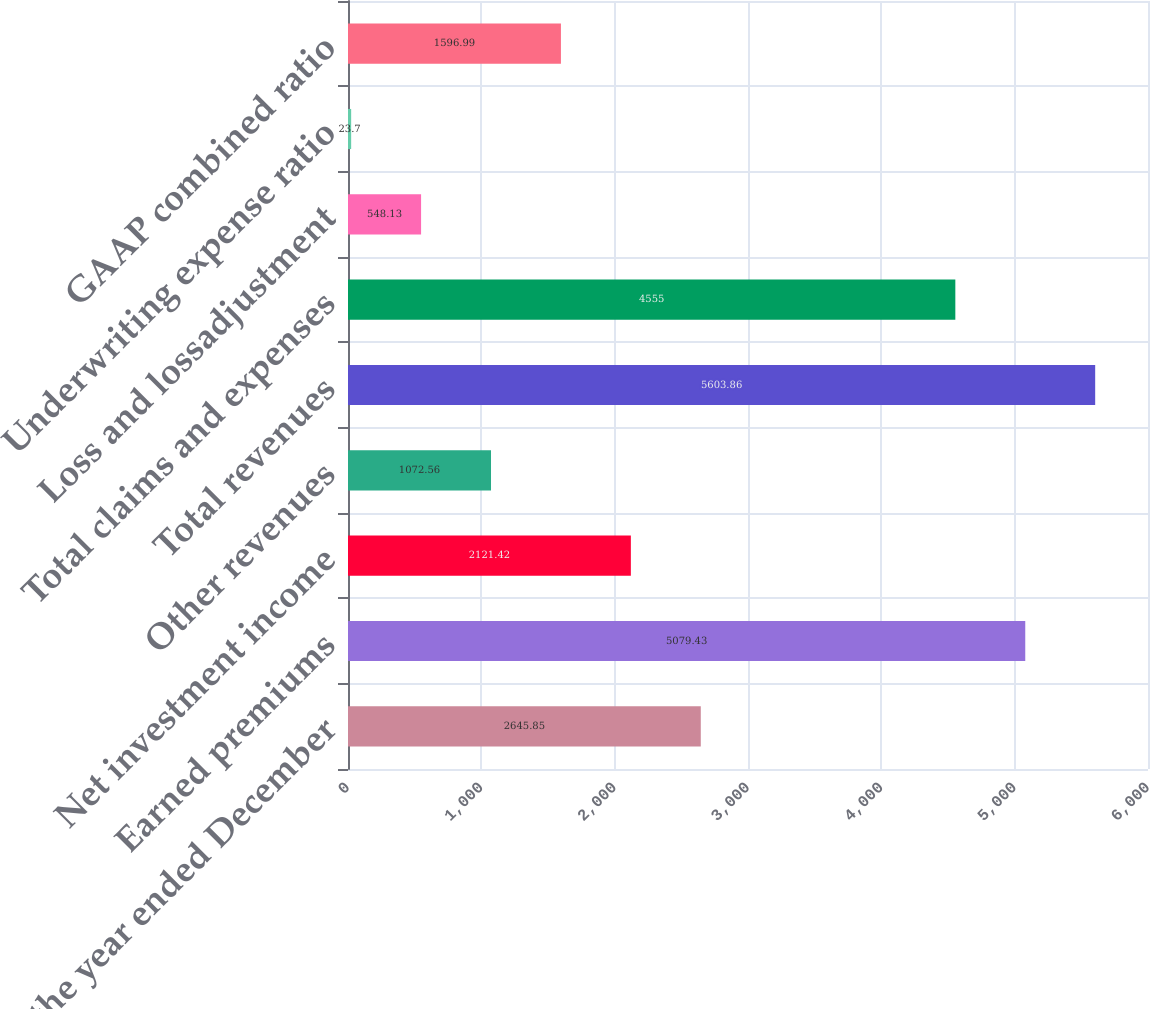Convert chart. <chart><loc_0><loc_0><loc_500><loc_500><bar_chart><fcel>(for the year ended December<fcel>Earned premiums<fcel>Net investment income<fcel>Other revenues<fcel>Total revenues<fcel>Total claims and expenses<fcel>Loss and lossadjustment<fcel>Underwriting expense ratio<fcel>GAAP combined ratio<nl><fcel>2645.85<fcel>5079.43<fcel>2121.42<fcel>1072.56<fcel>5603.86<fcel>4555<fcel>548.13<fcel>23.7<fcel>1596.99<nl></chart> 